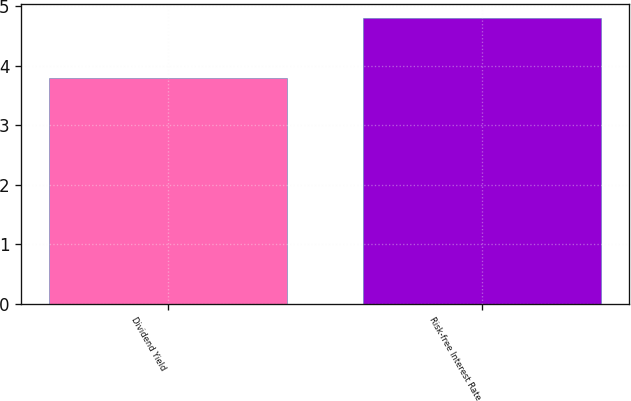Convert chart to OTSL. <chart><loc_0><loc_0><loc_500><loc_500><bar_chart><fcel>Dividend Yield<fcel>Risk-free Interest Rate<nl><fcel>3.79<fcel>4.8<nl></chart> 